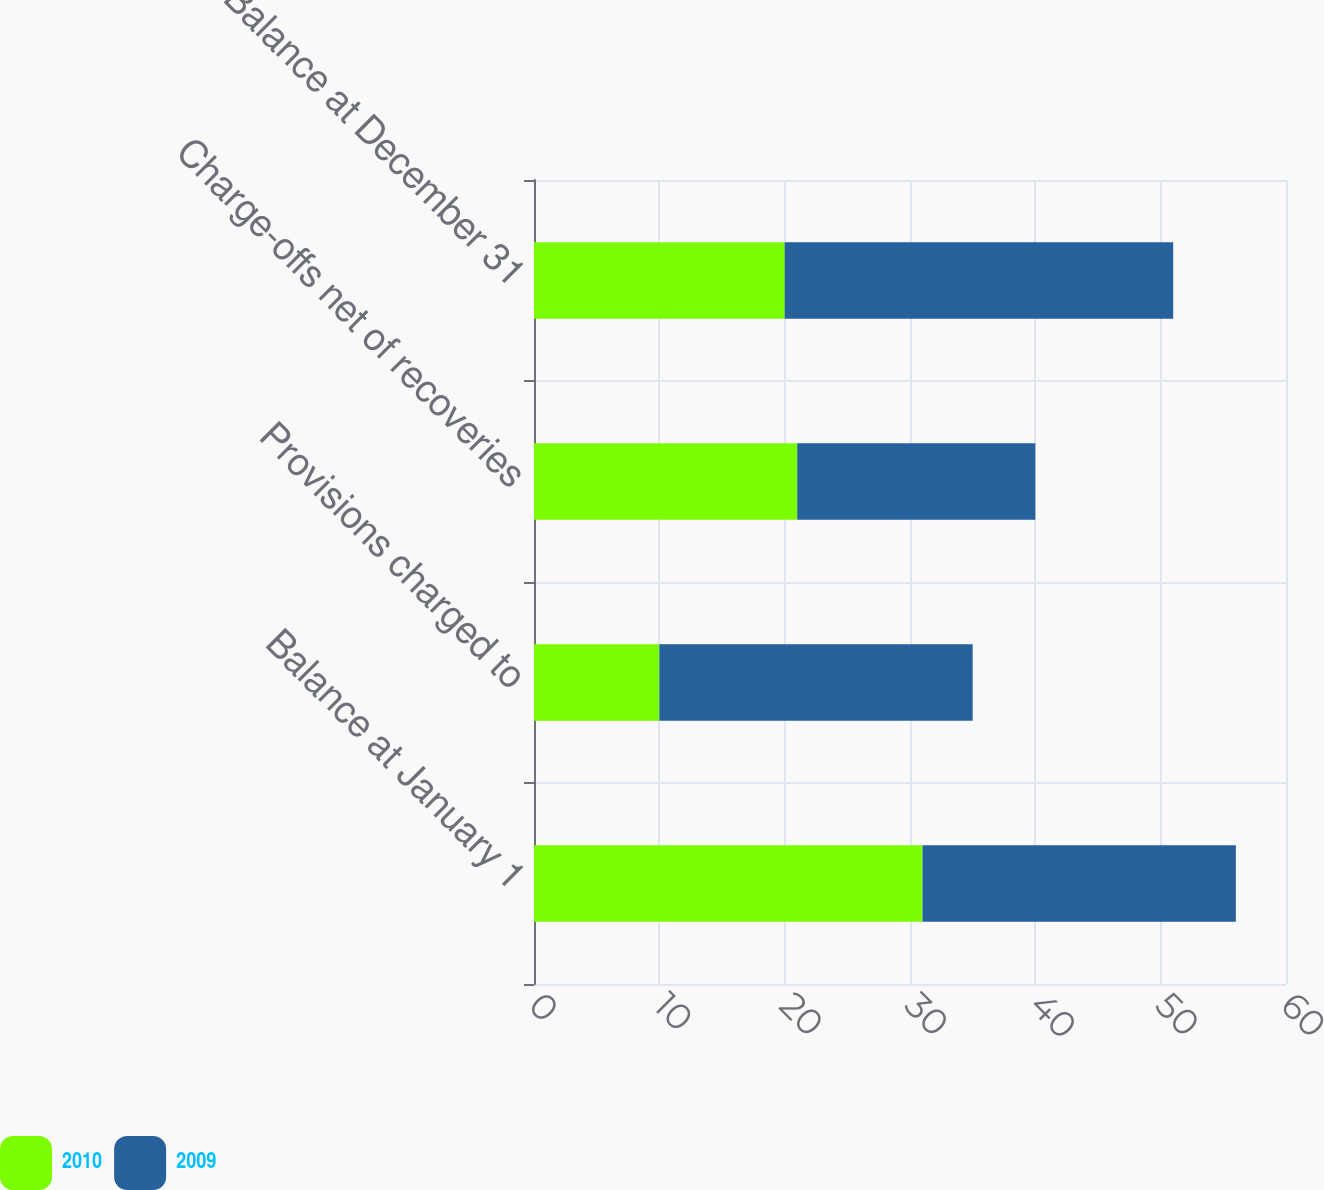Convert chart. <chart><loc_0><loc_0><loc_500><loc_500><stacked_bar_chart><ecel><fcel>Balance at January 1<fcel>Provisions charged to<fcel>Charge-offs net of recoveries<fcel>Balance at December 31<nl><fcel>2010<fcel>31<fcel>10<fcel>21<fcel>20<nl><fcel>2009<fcel>25<fcel>25<fcel>19<fcel>31<nl></chart> 